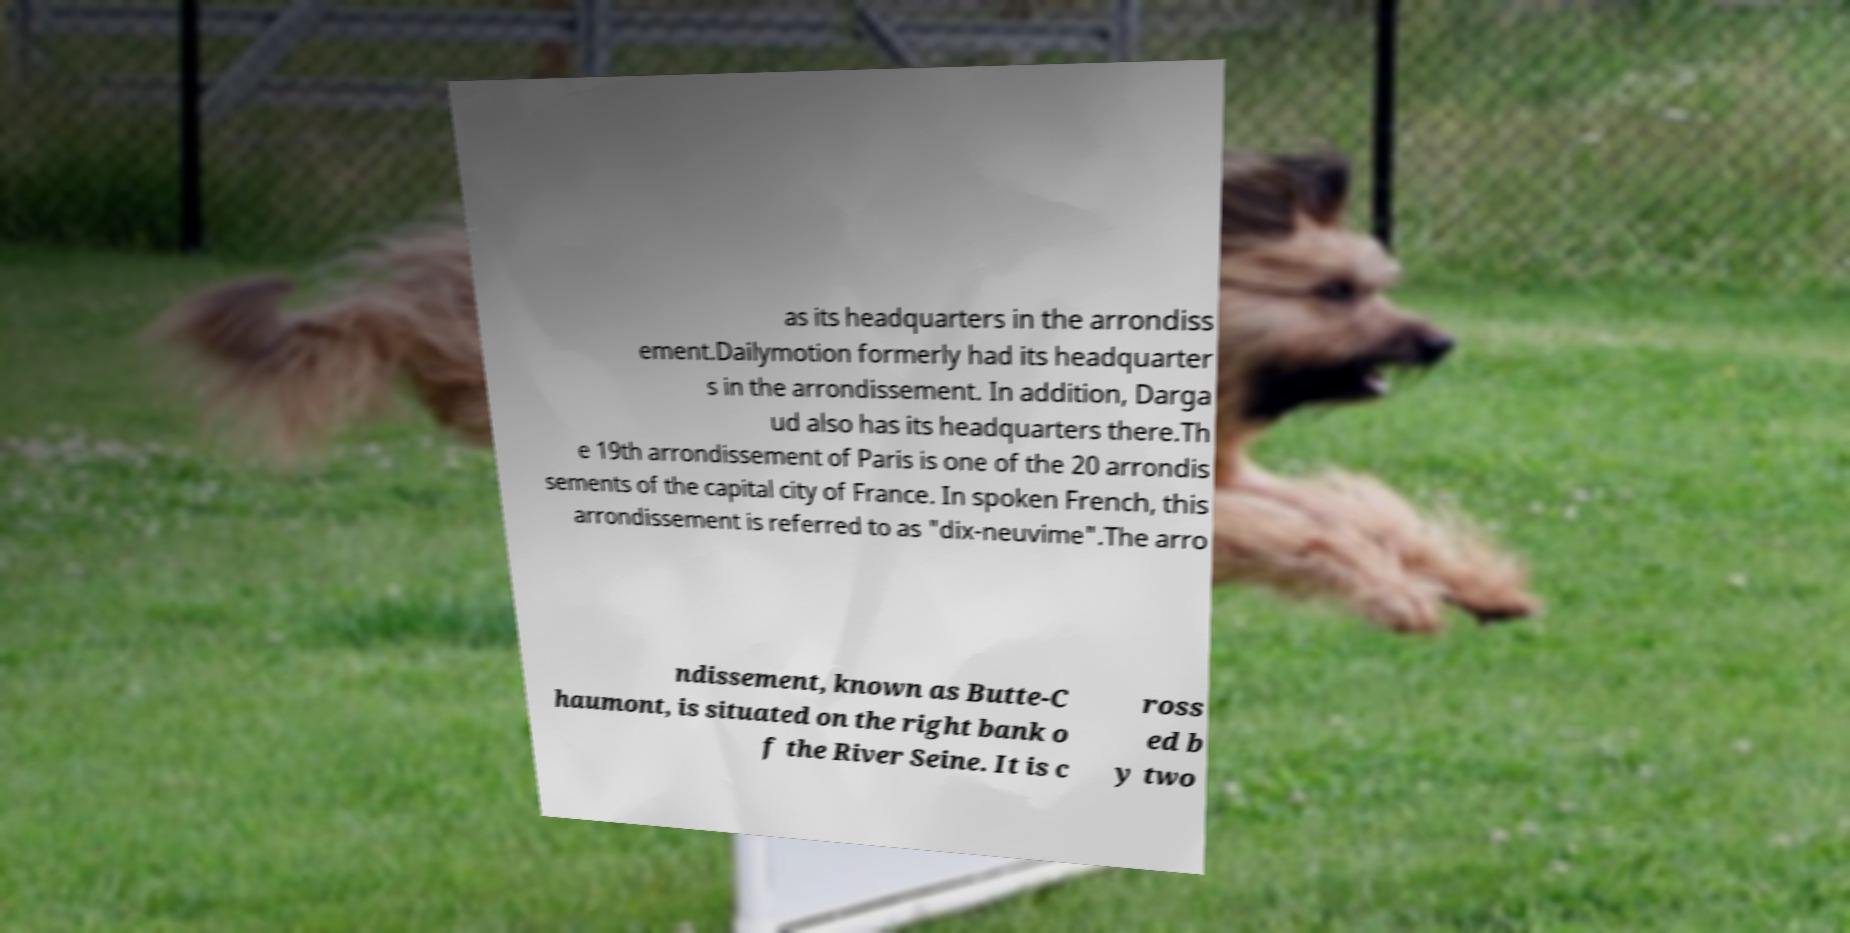Can you read and provide the text displayed in the image?This photo seems to have some interesting text. Can you extract and type it out for me? as its headquarters in the arrondiss ement.Dailymotion formerly had its headquarter s in the arrondissement. In addition, Darga ud also has its headquarters there.Th e 19th arrondissement of Paris is one of the 20 arrondis sements of the capital city of France. In spoken French, this arrondissement is referred to as "dix-neuvime".The arro ndissement, known as Butte-C haumont, is situated on the right bank o f the River Seine. It is c ross ed b y two 